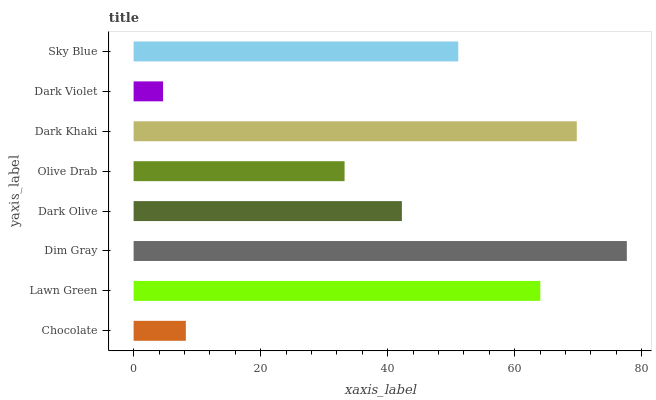Is Dark Violet the minimum?
Answer yes or no. Yes. Is Dim Gray the maximum?
Answer yes or no. Yes. Is Lawn Green the minimum?
Answer yes or no. No. Is Lawn Green the maximum?
Answer yes or no. No. Is Lawn Green greater than Chocolate?
Answer yes or no. Yes. Is Chocolate less than Lawn Green?
Answer yes or no. Yes. Is Chocolate greater than Lawn Green?
Answer yes or no. No. Is Lawn Green less than Chocolate?
Answer yes or no. No. Is Sky Blue the high median?
Answer yes or no. Yes. Is Dark Olive the low median?
Answer yes or no. Yes. Is Dark Olive the high median?
Answer yes or no. No. Is Sky Blue the low median?
Answer yes or no. No. 